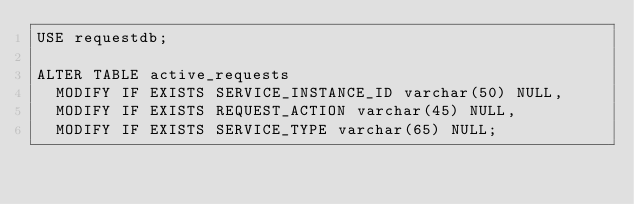Convert code to text. <code><loc_0><loc_0><loc_500><loc_500><_SQL_>USE requestdb;

ALTER TABLE active_requests 
  MODIFY IF EXISTS SERVICE_INSTANCE_ID varchar(50) NULL,
  MODIFY IF EXISTS REQUEST_ACTION varchar(45) NULL,
  MODIFY IF EXISTS SERVICE_TYPE varchar(65) NULL;</code> 